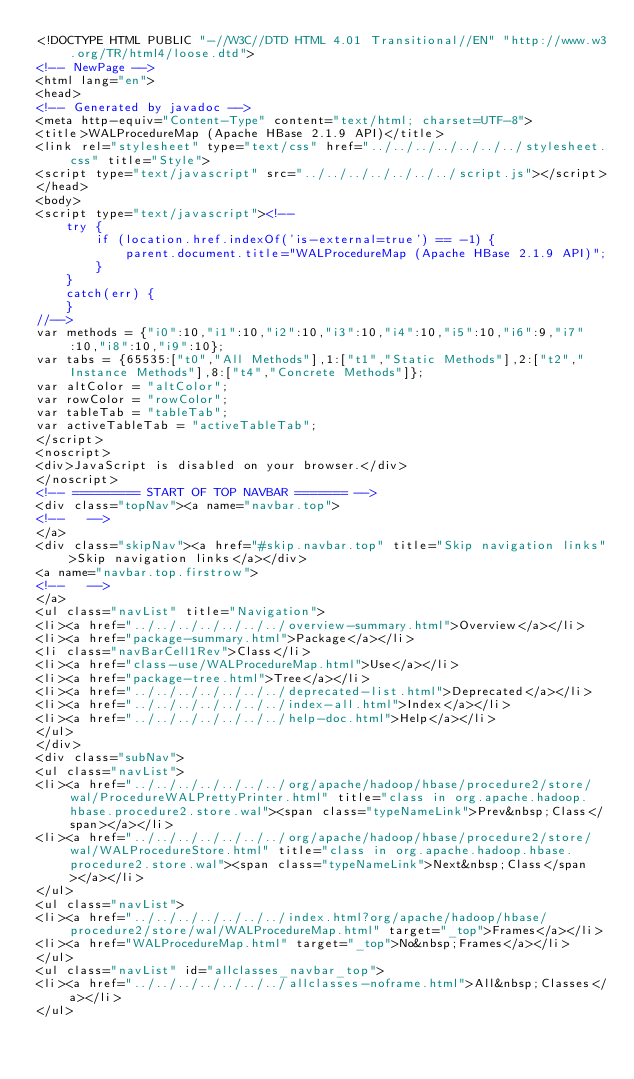Convert code to text. <code><loc_0><loc_0><loc_500><loc_500><_HTML_><!DOCTYPE HTML PUBLIC "-//W3C//DTD HTML 4.01 Transitional//EN" "http://www.w3.org/TR/html4/loose.dtd">
<!-- NewPage -->
<html lang="en">
<head>
<!-- Generated by javadoc -->
<meta http-equiv="Content-Type" content="text/html; charset=UTF-8">
<title>WALProcedureMap (Apache HBase 2.1.9 API)</title>
<link rel="stylesheet" type="text/css" href="../../../../../../../stylesheet.css" title="Style">
<script type="text/javascript" src="../../../../../../../script.js"></script>
</head>
<body>
<script type="text/javascript"><!--
    try {
        if (location.href.indexOf('is-external=true') == -1) {
            parent.document.title="WALProcedureMap (Apache HBase 2.1.9 API)";
        }
    }
    catch(err) {
    }
//-->
var methods = {"i0":10,"i1":10,"i2":10,"i3":10,"i4":10,"i5":10,"i6":9,"i7":10,"i8":10,"i9":10};
var tabs = {65535:["t0","All Methods"],1:["t1","Static Methods"],2:["t2","Instance Methods"],8:["t4","Concrete Methods"]};
var altColor = "altColor";
var rowColor = "rowColor";
var tableTab = "tableTab";
var activeTableTab = "activeTableTab";
</script>
<noscript>
<div>JavaScript is disabled on your browser.</div>
</noscript>
<!-- ========= START OF TOP NAVBAR ======= -->
<div class="topNav"><a name="navbar.top">
<!--   -->
</a>
<div class="skipNav"><a href="#skip.navbar.top" title="Skip navigation links">Skip navigation links</a></div>
<a name="navbar.top.firstrow">
<!--   -->
</a>
<ul class="navList" title="Navigation">
<li><a href="../../../../../../../overview-summary.html">Overview</a></li>
<li><a href="package-summary.html">Package</a></li>
<li class="navBarCell1Rev">Class</li>
<li><a href="class-use/WALProcedureMap.html">Use</a></li>
<li><a href="package-tree.html">Tree</a></li>
<li><a href="../../../../../../../deprecated-list.html">Deprecated</a></li>
<li><a href="../../../../../../../index-all.html">Index</a></li>
<li><a href="../../../../../../../help-doc.html">Help</a></li>
</ul>
</div>
<div class="subNav">
<ul class="navList">
<li><a href="../../../../../../../org/apache/hadoop/hbase/procedure2/store/wal/ProcedureWALPrettyPrinter.html" title="class in org.apache.hadoop.hbase.procedure2.store.wal"><span class="typeNameLink">Prev&nbsp;Class</span></a></li>
<li><a href="../../../../../../../org/apache/hadoop/hbase/procedure2/store/wal/WALProcedureStore.html" title="class in org.apache.hadoop.hbase.procedure2.store.wal"><span class="typeNameLink">Next&nbsp;Class</span></a></li>
</ul>
<ul class="navList">
<li><a href="../../../../../../../index.html?org/apache/hadoop/hbase/procedure2/store/wal/WALProcedureMap.html" target="_top">Frames</a></li>
<li><a href="WALProcedureMap.html" target="_top">No&nbsp;Frames</a></li>
</ul>
<ul class="navList" id="allclasses_navbar_top">
<li><a href="../../../../../../../allclasses-noframe.html">All&nbsp;Classes</a></li>
</ul></code> 